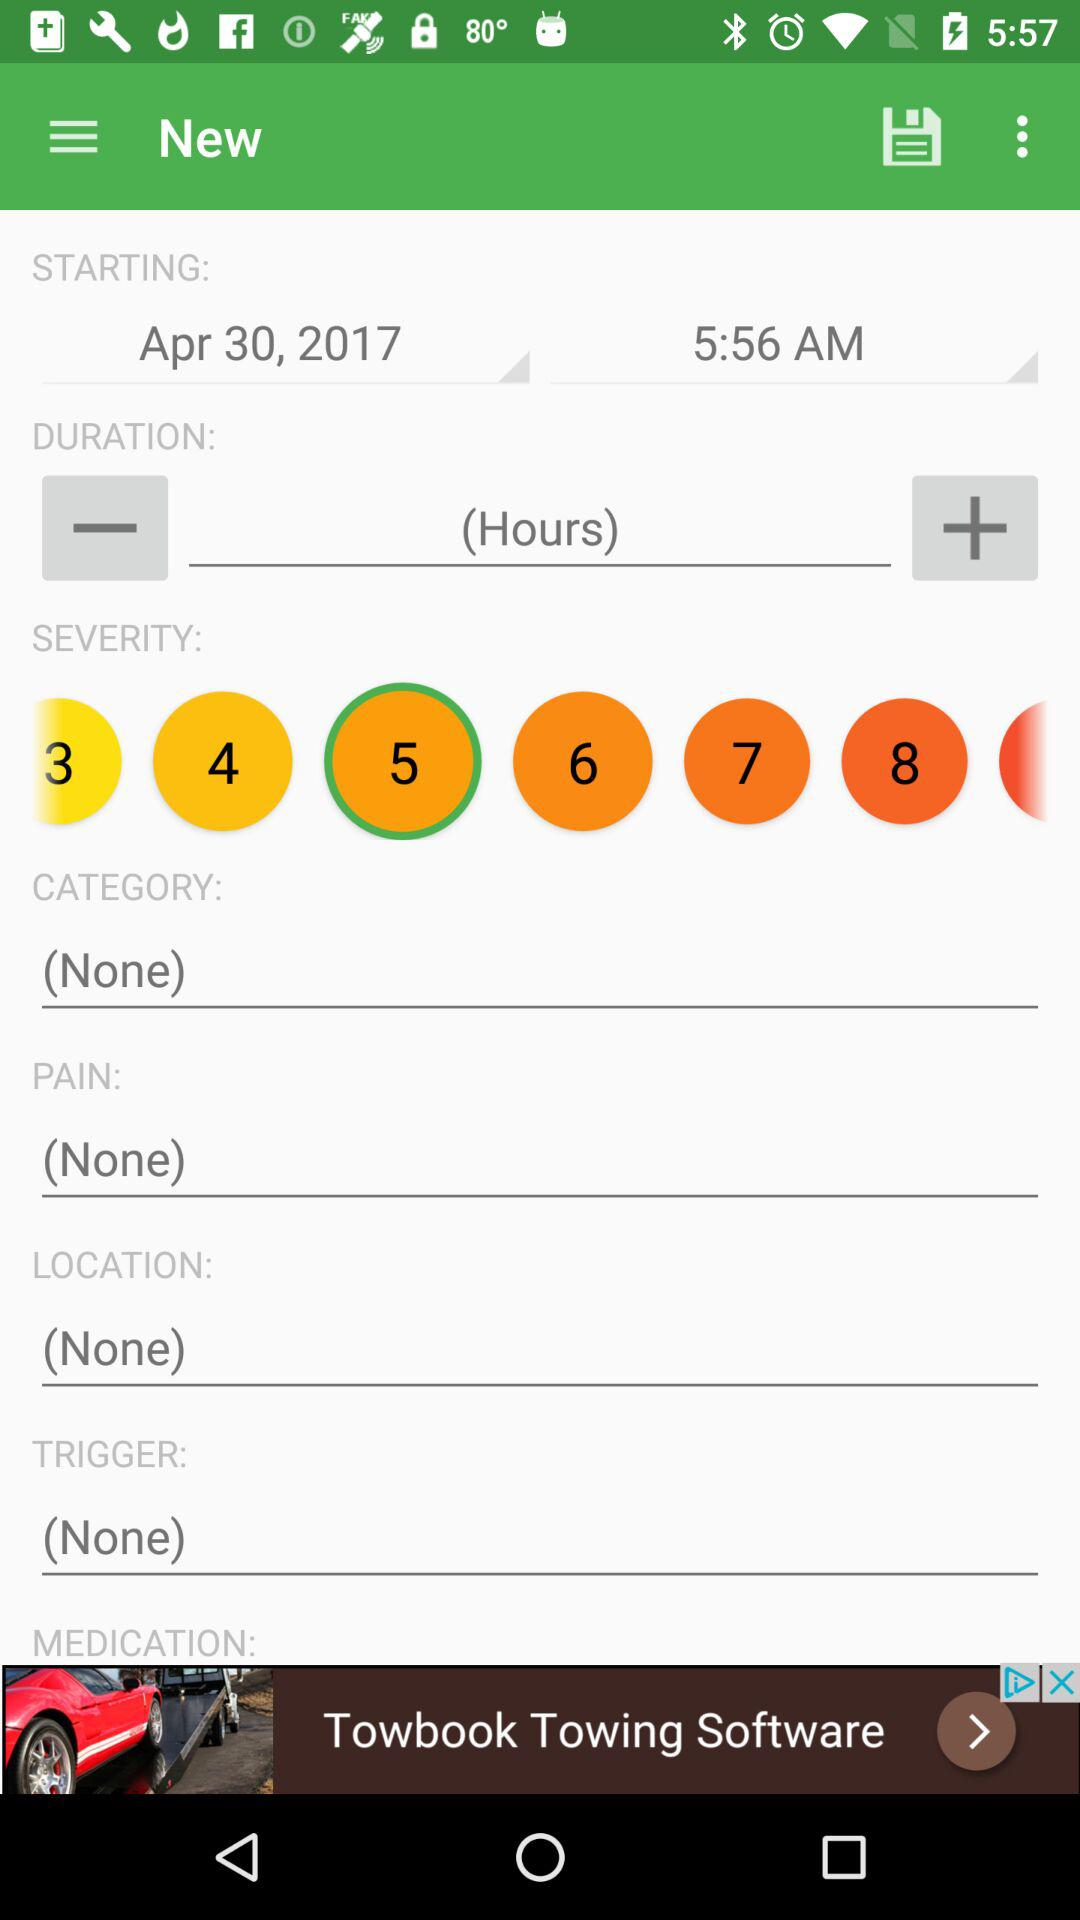Is this information saved?
When the provided information is insufficient, respond with <no answer>. <no answer> 